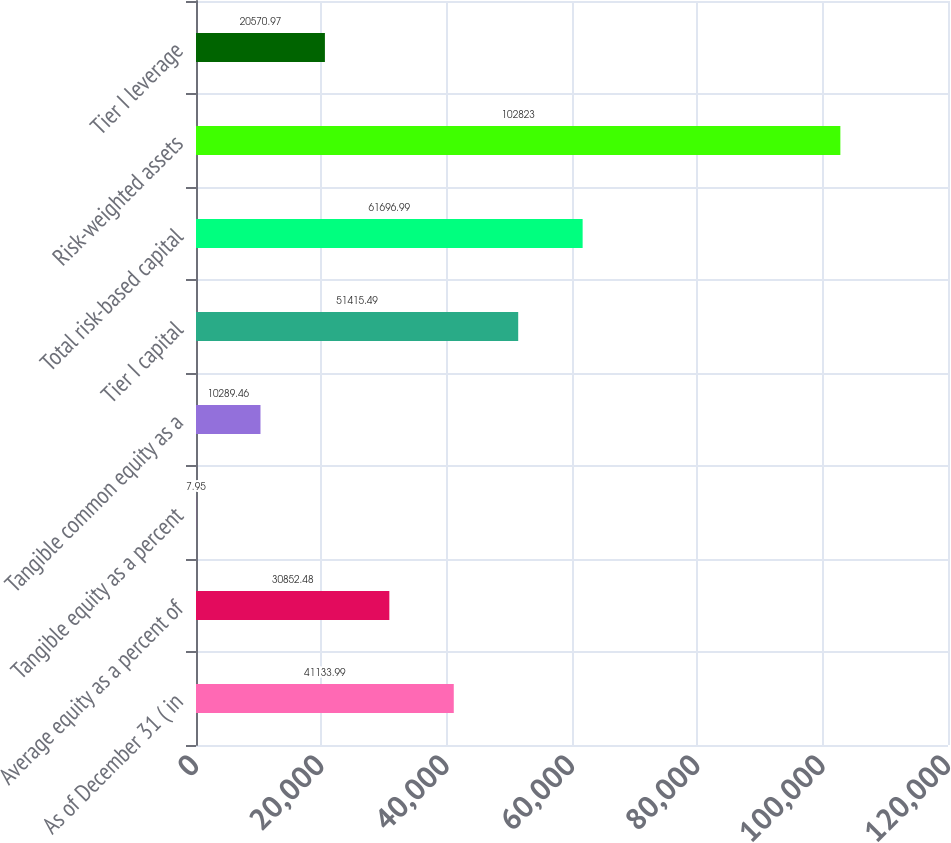Convert chart. <chart><loc_0><loc_0><loc_500><loc_500><bar_chart><fcel>As of December 31 ( in<fcel>Average equity as a percent of<fcel>Tangible equity as a percent<fcel>Tangible common equity as a<fcel>Tier I capital<fcel>Total risk-based capital<fcel>Risk-weighted assets<fcel>Tier I leverage<nl><fcel>41134<fcel>30852.5<fcel>7.95<fcel>10289.5<fcel>51415.5<fcel>61697<fcel>102823<fcel>20571<nl></chart> 